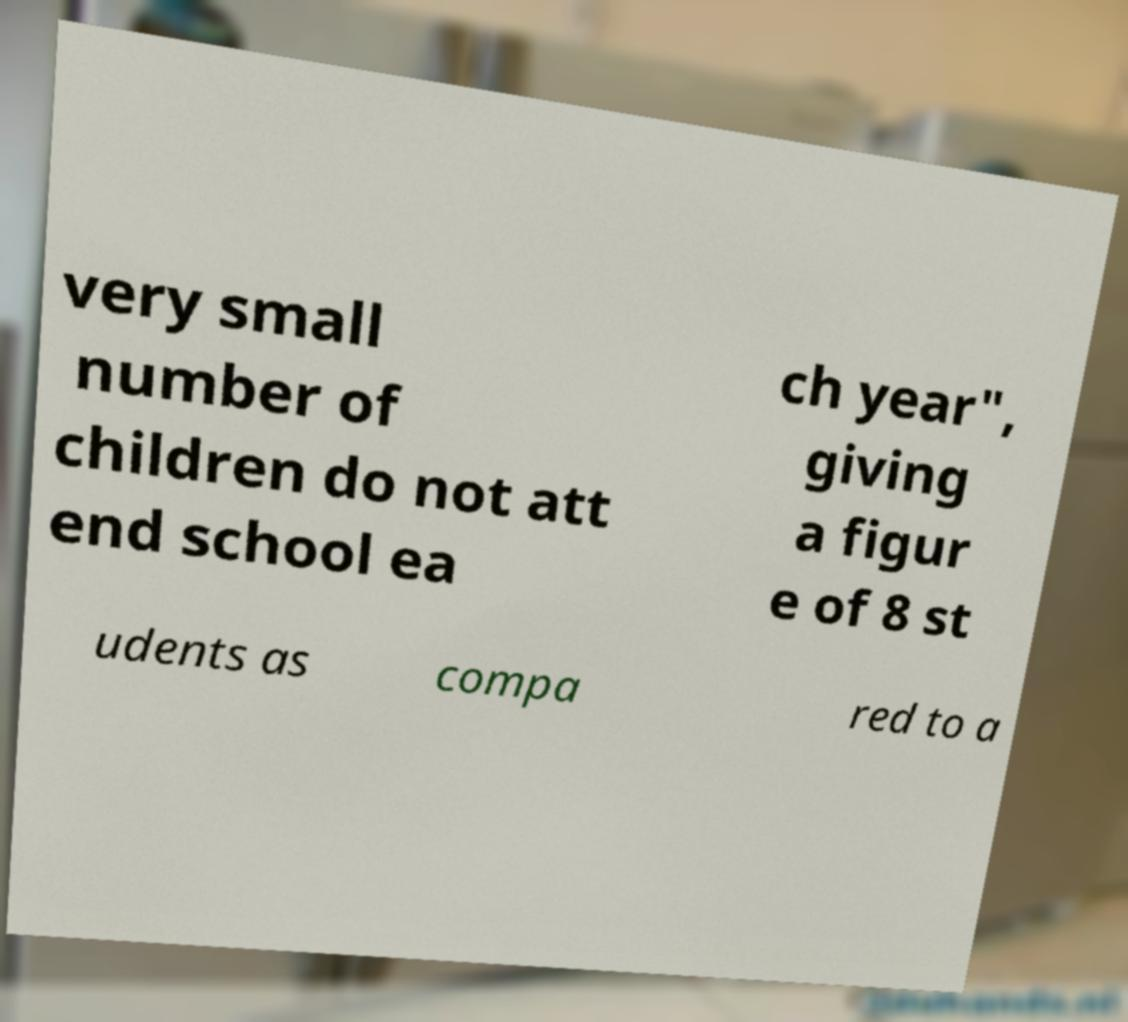For documentation purposes, I need the text within this image transcribed. Could you provide that? very small number of children do not att end school ea ch year", giving a figur e of 8 st udents as compa red to a 